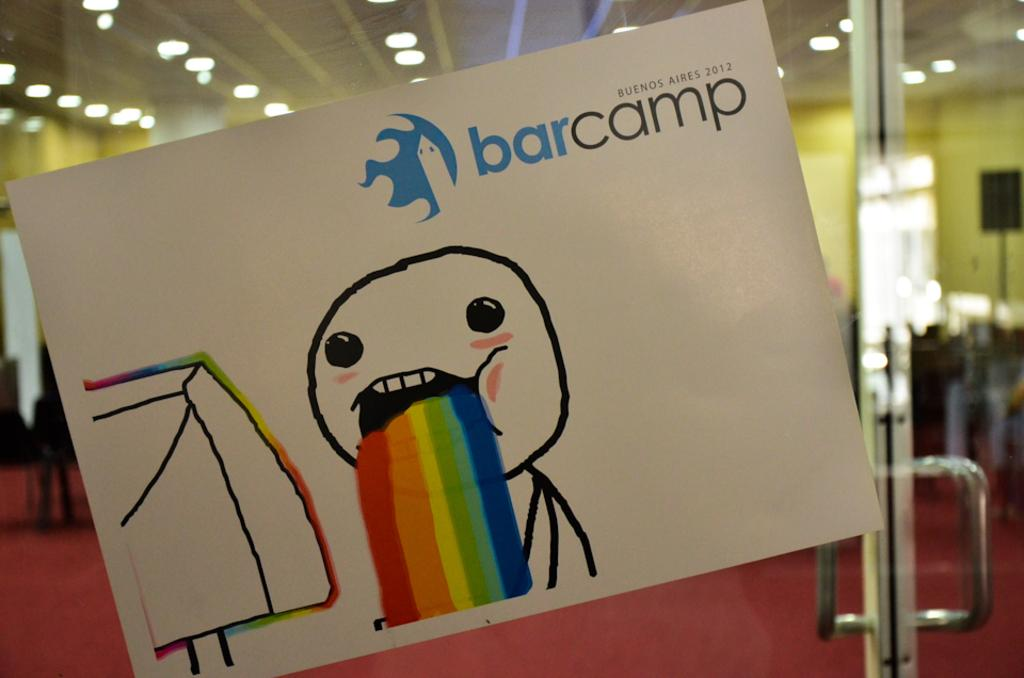<image>
Describe the image concisely. A stick figure barfing a rainbow with the word barcamp behind it. 